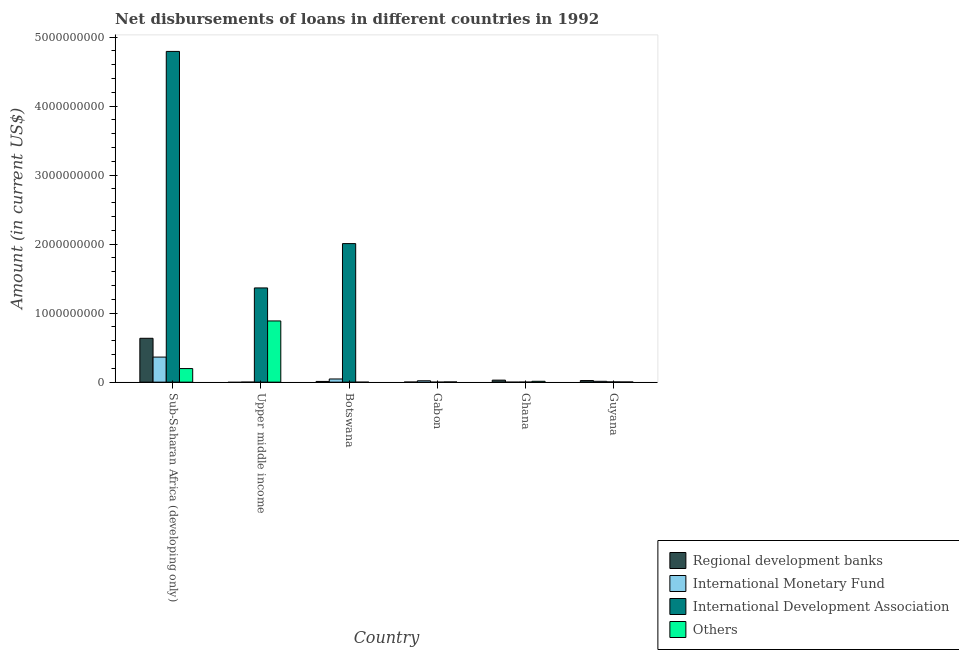How many groups of bars are there?
Provide a succinct answer. 6. Are the number of bars per tick equal to the number of legend labels?
Offer a very short reply. No. Are the number of bars on each tick of the X-axis equal?
Offer a very short reply. No. What is the label of the 5th group of bars from the left?
Provide a short and direct response. Ghana. What is the amount of loan disimbursed by regional development banks in Sub-Saharan Africa (developing only)?
Your answer should be very brief. 6.36e+08. Across all countries, what is the maximum amount of loan disimbursed by other organisations?
Ensure brevity in your answer.  8.87e+08. In which country was the amount of loan disimbursed by international monetary fund maximum?
Keep it short and to the point. Sub-Saharan Africa (developing only). What is the total amount of loan disimbursed by other organisations in the graph?
Make the answer very short. 1.10e+09. What is the difference between the amount of loan disimbursed by international monetary fund in Guyana and that in Sub-Saharan Africa (developing only)?
Provide a short and direct response. -3.51e+08. What is the difference between the amount of loan disimbursed by other organisations in Guyana and the amount of loan disimbursed by regional development banks in Botswana?
Provide a short and direct response. -8.21e+06. What is the average amount of loan disimbursed by other organisations per country?
Offer a very short reply. 1.84e+08. What is the difference between the amount of loan disimbursed by international development association and amount of loan disimbursed by other organisations in Guyana?
Ensure brevity in your answer.  1.00e+06. In how many countries, is the amount of loan disimbursed by international monetary fund greater than 4400000000 US$?
Your answer should be compact. 0. What is the ratio of the amount of loan disimbursed by other organisations in Gabon to that in Guyana?
Your response must be concise. 1.22. What is the difference between the highest and the second highest amount of loan disimbursed by regional development banks?
Your answer should be very brief. 6.07e+08. What is the difference between the highest and the lowest amount of loan disimbursed by international development association?
Give a very brief answer. 4.79e+09. In how many countries, is the amount of loan disimbursed by regional development banks greater than the average amount of loan disimbursed by regional development banks taken over all countries?
Make the answer very short. 1. Is the sum of the amount of loan disimbursed by regional development banks in Guyana and Sub-Saharan Africa (developing only) greater than the maximum amount of loan disimbursed by international development association across all countries?
Offer a terse response. No. Is it the case that in every country, the sum of the amount of loan disimbursed by international monetary fund and amount of loan disimbursed by international development association is greater than the sum of amount of loan disimbursed by regional development banks and amount of loan disimbursed by other organisations?
Ensure brevity in your answer.  No. Is it the case that in every country, the sum of the amount of loan disimbursed by regional development banks and amount of loan disimbursed by international monetary fund is greater than the amount of loan disimbursed by international development association?
Give a very brief answer. No. How many bars are there?
Provide a succinct answer. 18. What is the difference between two consecutive major ticks on the Y-axis?
Provide a succinct answer. 1.00e+09. Are the values on the major ticks of Y-axis written in scientific E-notation?
Provide a short and direct response. No. What is the title of the graph?
Make the answer very short. Net disbursements of loans in different countries in 1992. What is the label or title of the Y-axis?
Your answer should be very brief. Amount (in current US$). What is the Amount (in current US$) in Regional development banks in Sub-Saharan Africa (developing only)?
Your answer should be compact. 6.36e+08. What is the Amount (in current US$) in International Monetary Fund in Sub-Saharan Africa (developing only)?
Keep it short and to the point. 3.63e+08. What is the Amount (in current US$) in International Development Association in Sub-Saharan Africa (developing only)?
Offer a terse response. 4.79e+09. What is the Amount (in current US$) of Others in Sub-Saharan Africa (developing only)?
Your answer should be very brief. 1.97e+08. What is the Amount (in current US$) in International Monetary Fund in Upper middle income?
Your answer should be compact. 0. What is the Amount (in current US$) of International Development Association in Upper middle income?
Ensure brevity in your answer.  1.37e+09. What is the Amount (in current US$) of Others in Upper middle income?
Provide a succinct answer. 8.87e+08. What is the Amount (in current US$) of Regional development banks in Botswana?
Offer a terse response. 1.04e+07. What is the Amount (in current US$) in International Monetary Fund in Botswana?
Ensure brevity in your answer.  4.60e+07. What is the Amount (in current US$) of International Development Association in Botswana?
Your answer should be very brief. 2.01e+09. What is the Amount (in current US$) in Regional development banks in Gabon?
Provide a short and direct response. 9.91e+05. What is the Amount (in current US$) in International Monetary Fund in Gabon?
Your response must be concise. 1.99e+07. What is the Amount (in current US$) in International Development Association in Gabon?
Give a very brief answer. 0. What is the Amount (in current US$) in Others in Gabon?
Offer a very short reply. 2.66e+06. What is the Amount (in current US$) of Regional development banks in Ghana?
Keep it short and to the point. 2.91e+07. What is the Amount (in current US$) in International Monetary Fund in Ghana?
Your answer should be very brief. 0. What is the Amount (in current US$) in International Development Association in Ghana?
Make the answer very short. 0. What is the Amount (in current US$) in Others in Ghana?
Your answer should be compact. 1.25e+07. What is the Amount (in current US$) of Regional development banks in Guyana?
Make the answer very short. 2.32e+07. What is the Amount (in current US$) of International Monetary Fund in Guyana?
Provide a succinct answer. 1.22e+07. What is the Amount (in current US$) of International Development Association in Guyana?
Your answer should be compact. 3.19e+06. What is the Amount (in current US$) of Others in Guyana?
Ensure brevity in your answer.  2.18e+06. Across all countries, what is the maximum Amount (in current US$) in Regional development banks?
Your response must be concise. 6.36e+08. Across all countries, what is the maximum Amount (in current US$) of International Monetary Fund?
Make the answer very short. 3.63e+08. Across all countries, what is the maximum Amount (in current US$) of International Development Association?
Offer a terse response. 4.79e+09. Across all countries, what is the maximum Amount (in current US$) of Others?
Your answer should be compact. 8.87e+08. Across all countries, what is the minimum Amount (in current US$) in Regional development banks?
Keep it short and to the point. 0. Across all countries, what is the minimum Amount (in current US$) in International Monetary Fund?
Your response must be concise. 0. What is the total Amount (in current US$) of Regional development banks in the graph?
Give a very brief answer. 6.99e+08. What is the total Amount (in current US$) in International Monetary Fund in the graph?
Give a very brief answer. 4.41e+08. What is the total Amount (in current US$) of International Development Association in the graph?
Provide a succinct answer. 8.17e+09. What is the total Amount (in current US$) of Others in the graph?
Your answer should be compact. 1.10e+09. What is the difference between the Amount (in current US$) in International Development Association in Sub-Saharan Africa (developing only) and that in Upper middle income?
Offer a very short reply. 3.43e+09. What is the difference between the Amount (in current US$) of Others in Sub-Saharan Africa (developing only) and that in Upper middle income?
Ensure brevity in your answer.  -6.90e+08. What is the difference between the Amount (in current US$) in Regional development banks in Sub-Saharan Africa (developing only) and that in Botswana?
Offer a very short reply. 6.25e+08. What is the difference between the Amount (in current US$) of International Monetary Fund in Sub-Saharan Africa (developing only) and that in Botswana?
Provide a succinct answer. 3.17e+08. What is the difference between the Amount (in current US$) in International Development Association in Sub-Saharan Africa (developing only) and that in Botswana?
Provide a short and direct response. 2.79e+09. What is the difference between the Amount (in current US$) in Regional development banks in Sub-Saharan Africa (developing only) and that in Gabon?
Offer a very short reply. 6.35e+08. What is the difference between the Amount (in current US$) of International Monetary Fund in Sub-Saharan Africa (developing only) and that in Gabon?
Give a very brief answer. 3.43e+08. What is the difference between the Amount (in current US$) of Others in Sub-Saharan Africa (developing only) and that in Gabon?
Make the answer very short. 1.94e+08. What is the difference between the Amount (in current US$) in Regional development banks in Sub-Saharan Africa (developing only) and that in Ghana?
Your response must be concise. 6.07e+08. What is the difference between the Amount (in current US$) of Others in Sub-Saharan Africa (developing only) and that in Ghana?
Your response must be concise. 1.84e+08. What is the difference between the Amount (in current US$) in Regional development banks in Sub-Saharan Africa (developing only) and that in Guyana?
Offer a very short reply. 6.13e+08. What is the difference between the Amount (in current US$) in International Monetary Fund in Sub-Saharan Africa (developing only) and that in Guyana?
Your answer should be very brief. 3.51e+08. What is the difference between the Amount (in current US$) in International Development Association in Sub-Saharan Africa (developing only) and that in Guyana?
Your answer should be compact. 4.79e+09. What is the difference between the Amount (in current US$) in Others in Sub-Saharan Africa (developing only) and that in Guyana?
Your answer should be compact. 1.95e+08. What is the difference between the Amount (in current US$) in International Development Association in Upper middle income and that in Botswana?
Give a very brief answer. -6.43e+08. What is the difference between the Amount (in current US$) in Others in Upper middle income and that in Gabon?
Give a very brief answer. 8.84e+08. What is the difference between the Amount (in current US$) of Others in Upper middle income and that in Ghana?
Your response must be concise. 8.75e+08. What is the difference between the Amount (in current US$) in International Development Association in Upper middle income and that in Guyana?
Keep it short and to the point. 1.36e+09. What is the difference between the Amount (in current US$) in Others in Upper middle income and that in Guyana?
Ensure brevity in your answer.  8.85e+08. What is the difference between the Amount (in current US$) in Regional development banks in Botswana and that in Gabon?
Provide a short and direct response. 9.40e+06. What is the difference between the Amount (in current US$) in International Monetary Fund in Botswana and that in Gabon?
Offer a very short reply. 2.61e+07. What is the difference between the Amount (in current US$) of Regional development banks in Botswana and that in Ghana?
Your answer should be very brief. -1.88e+07. What is the difference between the Amount (in current US$) of Regional development banks in Botswana and that in Guyana?
Keep it short and to the point. -1.28e+07. What is the difference between the Amount (in current US$) in International Monetary Fund in Botswana and that in Guyana?
Provide a short and direct response. 3.38e+07. What is the difference between the Amount (in current US$) of International Development Association in Botswana and that in Guyana?
Give a very brief answer. 2.00e+09. What is the difference between the Amount (in current US$) of Regional development banks in Gabon and that in Ghana?
Provide a short and direct response. -2.82e+07. What is the difference between the Amount (in current US$) of Others in Gabon and that in Ghana?
Make the answer very short. -9.86e+06. What is the difference between the Amount (in current US$) in Regional development banks in Gabon and that in Guyana?
Provide a short and direct response. -2.22e+07. What is the difference between the Amount (in current US$) in International Monetary Fund in Gabon and that in Guyana?
Ensure brevity in your answer.  7.66e+06. What is the difference between the Amount (in current US$) in Others in Gabon and that in Guyana?
Keep it short and to the point. 4.79e+05. What is the difference between the Amount (in current US$) of Regional development banks in Ghana and that in Guyana?
Offer a terse response. 5.97e+06. What is the difference between the Amount (in current US$) of Others in Ghana and that in Guyana?
Offer a very short reply. 1.03e+07. What is the difference between the Amount (in current US$) in Regional development banks in Sub-Saharan Africa (developing only) and the Amount (in current US$) in International Development Association in Upper middle income?
Keep it short and to the point. -7.30e+08. What is the difference between the Amount (in current US$) of Regional development banks in Sub-Saharan Africa (developing only) and the Amount (in current US$) of Others in Upper middle income?
Your response must be concise. -2.51e+08. What is the difference between the Amount (in current US$) in International Monetary Fund in Sub-Saharan Africa (developing only) and the Amount (in current US$) in International Development Association in Upper middle income?
Provide a short and direct response. -1.00e+09. What is the difference between the Amount (in current US$) in International Monetary Fund in Sub-Saharan Africa (developing only) and the Amount (in current US$) in Others in Upper middle income?
Keep it short and to the point. -5.24e+08. What is the difference between the Amount (in current US$) of International Development Association in Sub-Saharan Africa (developing only) and the Amount (in current US$) of Others in Upper middle income?
Keep it short and to the point. 3.91e+09. What is the difference between the Amount (in current US$) of Regional development banks in Sub-Saharan Africa (developing only) and the Amount (in current US$) of International Monetary Fund in Botswana?
Your answer should be compact. 5.90e+08. What is the difference between the Amount (in current US$) in Regional development banks in Sub-Saharan Africa (developing only) and the Amount (in current US$) in International Development Association in Botswana?
Offer a terse response. -1.37e+09. What is the difference between the Amount (in current US$) in International Monetary Fund in Sub-Saharan Africa (developing only) and the Amount (in current US$) in International Development Association in Botswana?
Provide a short and direct response. -1.64e+09. What is the difference between the Amount (in current US$) in Regional development banks in Sub-Saharan Africa (developing only) and the Amount (in current US$) in International Monetary Fund in Gabon?
Your answer should be compact. 6.16e+08. What is the difference between the Amount (in current US$) of Regional development banks in Sub-Saharan Africa (developing only) and the Amount (in current US$) of Others in Gabon?
Your response must be concise. 6.33e+08. What is the difference between the Amount (in current US$) in International Monetary Fund in Sub-Saharan Africa (developing only) and the Amount (in current US$) in Others in Gabon?
Offer a very short reply. 3.60e+08. What is the difference between the Amount (in current US$) of International Development Association in Sub-Saharan Africa (developing only) and the Amount (in current US$) of Others in Gabon?
Your answer should be compact. 4.79e+09. What is the difference between the Amount (in current US$) of Regional development banks in Sub-Saharan Africa (developing only) and the Amount (in current US$) of Others in Ghana?
Your answer should be very brief. 6.23e+08. What is the difference between the Amount (in current US$) in International Monetary Fund in Sub-Saharan Africa (developing only) and the Amount (in current US$) in Others in Ghana?
Your response must be concise. 3.51e+08. What is the difference between the Amount (in current US$) of International Development Association in Sub-Saharan Africa (developing only) and the Amount (in current US$) of Others in Ghana?
Give a very brief answer. 4.78e+09. What is the difference between the Amount (in current US$) in Regional development banks in Sub-Saharan Africa (developing only) and the Amount (in current US$) in International Monetary Fund in Guyana?
Offer a very short reply. 6.23e+08. What is the difference between the Amount (in current US$) in Regional development banks in Sub-Saharan Africa (developing only) and the Amount (in current US$) in International Development Association in Guyana?
Your response must be concise. 6.33e+08. What is the difference between the Amount (in current US$) of Regional development banks in Sub-Saharan Africa (developing only) and the Amount (in current US$) of Others in Guyana?
Provide a succinct answer. 6.34e+08. What is the difference between the Amount (in current US$) of International Monetary Fund in Sub-Saharan Africa (developing only) and the Amount (in current US$) of International Development Association in Guyana?
Provide a short and direct response. 3.60e+08. What is the difference between the Amount (in current US$) of International Monetary Fund in Sub-Saharan Africa (developing only) and the Amount (in current US$) of Others in Guyana?
Your response must be concise. 3.61e+08. What is the difference between the Amount (in current US$) in International Development Association in Sub-Saharan Africa (developing only) and the Amount (in current US$) in Others in Guyana?
Keep it short and to the point. 4.79e+09. What is the difference between the Amount (in current US$) in International Development Association in Upper middle income and the Amount (in current US$) in Others in Gabon?
Your answer should be compact. 1.36e+09. What is the difference between the Amount (in current US$) of International Development Association in Upper middle income and the Amount (in current US$) of Others in Ghana?
Offer a terse response. 1.35e+09. What is the difference between the Amount (in current US$) of International Development Association in Upper middle income and the Amount (in current US$) of Others in Guyana?
Keep it short and to the point. 1.36e+09. What is the difference between the Amount (in current US$) of Regional development banks in Botswana and the Amount (in current US$) of International Monetary Fund in Gabon?
Make the answer very short. -9.50e+06. What is the difference between the Amount (in current US$) in Regional development banks in Botswana and the Amount (in current US$) in Others in Gabon?
Give a very brief answer. 7.73e+06. What is the difference between the Amount (in current US$) of International Monetary Fund in Botswana and the Amount (in current US$) of Others in Gabon?
Your answer should be very brief. 4.33e+07. What is the difference between the Amount (in current US$) of International Development Association in Botswana and the Amount (in current US$) of Others in Gabon?
Your response must be concise. 2.01e+09. What is the difference between the Amount (in current US$) of Regional development banks in Botswana and the Amount (in current US$) of Others in Ghana?
Make the answer very short. -2.13e+06. What is the difference between the Amount (in current US$) in International Monetary Fund in Botswana and the Amount (in current US$) in Others in Ghana?
Provide a succinct answer. 3.35e+07. What is the difference between the Amount (in current US$) in International Development Association in Botswana and the Amount (in current US$) in Others in Ghana?
Provide a short and direct response. 2.00e+09. What is the difference between the Amount (in current US$) in Regional development banks in Botswana and the Amount (in current US$) in International Monetary Fund in Guyana?
Provide a short and direct response. -1.84e+06. What is the difference between the Amount (in current US$) in Regional development banks in Botswana and the Amount (in current US$) in International Development Association in Guyana?
Your response must be concise. 7.20e+06. What is the difference between the Amount (in current US$) in Regional development banks in Botswana and the Amount (in current US$) in Others in Guyana?
Provide a succinct answer. 8.21e+06. What is the difference between the Amount (in current US$) in International Monetary Fund in Botswana and the Amount (in current US$) in International Development Association in Guyana?
Your response must be concise. 4.28e+07. What is the difference between the Amount (in current US$) in International Monetary Fund in Botswana and the Amount (in current US$) in Others in Guyana?
Your answer should be very brief. 4.38e+07. What is the difference between the Amount (in current US$) of International Development Association in Botswana and the Amount (in current US$) of Others in Guyana?
Your response must be concise. 2.01e+09. What is the difference between the Amount (in current US$) of Regional development banks in Gabon and the Amount (in current US$) of Others in Ghana?
Your response must be concise. -1.15e+07. What is the difference between the Amount (in current US$) of International Monetary Fund in Gabon and the Amount (in current US$) of Others in Ghana?
Ensure brevity in your answer.  7.36e+06. What is the difference between the Amount (in current US$) in Regional development banks in Gabon and the Amount (in current US$) in International Monetary Fund in Guyana?
Your answer should be compact. -1.12e+07. What is the difference between the Amount (in current US$) of Regional development banks in Gabon and the Amount (in current US$) of International Development Association in Guyana?
Offer a terse response. -2.20e+06. What is the difference between the Amount (in current US$) in Regional development banks in Gabon and the Amount (in current US$) in Others in Guyana?
Your response must be concise. -1.19e+06. What is the difference between the Amount (in current US$) in International Monetary Fund in Gabon and the Amount (in current US$) in International Development Association in Guyana?
Provide a short and direct response. 1.67e+07. What is the difference between the Amount (in current US$) in International Monetary Fund in Gabon and the Amount (in current US$) in Others in Guyana?
Provide a succinct answer. 1.77e+07. What is the difference between the Amount (in current US$) in Regional development banks in Ghana and the Amount (in current US$) in International Monetary Fund in Guyana?
Your response must be concise. 1.69e+07. What is the difference between the Amount (in current US$) in Regional development banks in Ghana and the Amount (in current US$) in International Development Association in Guyana?
Make the answer very short. 2.60e+07. What is the difference between the Amount (in current US$) in Regional development banks in Ghana and the Amount (in current US$) in Others in Guyana?
Provide a succinct answer. 2.70e+07. What is the average Amount (in current US$) of Regional development banks per country?
Give a very brief answer. 1.17e+08. What is the average Amount (in current US$) in International Monetary Fund per country?
Give a very brief answer. 7.35e+07. What is the average Amount (in current US$) in International Development Association per country?
Ensure brevity in your answer.  1.36e+09. What is the average Amount (in current US$) in Others per country?
Offer a very short reply. 1.84e+08. What is the difference between the Amount (in current US$) of Regional development banks and Amount (in current US$) of International Monetary Fund in Sub-Saharan Africa (developing only)?
Offer a terse response. 2.73e+08. What is the difference between the Amount (in current US$) in Regional development banks and Amount (in current US$) in International Development Association in Sub-Saharan Africa (developing only)?
Your answer should be very brief. -4.16e+09. What is the difference between the Amount (in current US$) in Regional development banks and Amount (in current US$) in Others in Sub-Saharan Africa (developing only)?
Your answer should be very brief. 4.39e+08. What is the difference between the Amount (in current US$) of International Monetary Fund and Amount (in current US$) of International Development Association in Sub-Saharan Africa (developing only)?
Give a very brief answer. -4.43e+09. What is the difference between the Amount (in current US$) of International Monetary Fund and Amount (in current US$) of Others in Sub-Saharan Africa (developing only)?
Offer a very short reply. 1.66e+08. What is the difference between the Amount (in current US$) of International Development Association and Amount (in current US$) of Others in Sub-Saharan Africa (developing only)?
Offer a terse response. 4.60e+09. What is the difference between the Amount (in current US$) in International Development Association and Amount (in current US$) in Others in Upper middle income?
Offer a terse response. 4.78e+08. What is the difference between the Amount (in current US$) of Regional development banks and Amount (in current US$) of International Monetary Fund in Botswana?
Make the answer very short. -3.56e+07. What is the difference between the Amount (in current US$) of Regional development banks and Amount (in current US$) of International Development Association in Botswana?
Offer a very short reply. -2.00e+09. What is the difference between the Amount (in current US$) in International Monetary Fund and Amount (in current US$) in International Development Association in Botswana?
Provide a short and direct response. -1.96e+09. What is the difference between the Amount (in current US$) in Regional development banks and Amount (in current US$) in International Monetary Fund in Gabon?
Keep it short and to the point. -1.89e+07. What is the difference between the Amount (in current US$) in Regional development banks and Amount (in current US$) in Others in Gabon?
Your answer should be compact. -1.67e+06. What is the difference between the Amount (in current US$) in International Monetary Fund and Amount (in current US$) in Others in Gabon?
Offer a terse response. 1.72e+07. What is the difference between the Amount (in current US$) of Regional development banks and Amount (in current US$) of Others in Ghana?
Provide a short and direct response. 1.66e+07. What is the difference between the Amount (in current US$) in Regional development banks and Amount (in current US$) in International Monetary Fund in Guyana?
Keep it short and to the point. 1.09e+07. What is the difference between the Amount (in current US$) of Regional development banks and Amount (in current US$) of International Development Association in Guyana?
Provide a short and direct response. 2.00e+07. What is the difference between the Amount (in current US$) in Regional development banks and Amount (in current US$) in Others in Guyana?
Make the answer very short. 2.10e+07. What is the difference between the Amount (in current US$) of International Monetary Fund and Amount (in current US$) of International Development Association in Guyana?
Provide a short and direct response. 9.05e+06. What is the difference between the Amount (in current US$) of International Monetary Fund and Amount (in current US$) of Others in Guyana?
Offer a very short reply. 1.00e+07. What is the difference between the Amount (in current US$) of International Development Association and Amount (in current US$) of Others in Guyana?
Provide a short and direct response. 1.00e+06. What is the ratio of the Amount (in current US$) in International Development Association in Sub-Saharan Africa (developing only) to that in Upper middle income?
Keep it short and to the point. 3.51. What is the ratio of the Amount (in current US$) in Others in Sub-Saharan Africa (developing only) to that in Upper middle income?
Your response must be concise. 0.22. What is the ratio of the Amount (in current US$) of Regional development banks in Sub-Saharan Africa (developing only) to that in Botswana?
Make the answer very short. 61.17. What is the ratio of the Amount (in current US$) of International Monetary Fund in Sub-Saharan Africa (developing only) to that in Botswana?
Provide a succinct answer. 7.9. What is the ratio of the Amount (in current US$) of International Development Association in Sub-Saharan Africa (developing only) to that in Botswana?
Provide a short and direct response. 2.39. What is the ratio of the Amount (in current US$) of Regional development banks in Sub-Saharan Africa (developing only) to that in Gabon?
Provide a short and direct response. 641.46. What is the ratio of the Amount (in current US$) in International Monetary Fund in Sub-Saharan Africa (developing only) to that in Gabon?
Your answer should be very brief. 18.26. What is the ratio of the Amount (in current US$) of Others in Sub-Saharan Africa (developing only) to that in Gabon?
Keep it short and to the point. 73.91. What is the ratio of the Amount (in current US$) in Regional development banks in Sub-Saharan Africa (developing only) to that in Ghana?
Make the answer very short. 21.81. What is the ratio of the Amount (in current US$) in Others in Sub-Saharan Africa (developing only) to that in Ghana?
Keep it short and to the point. 15.71. What is the ratio of the Amount (in current US$) in Regional development banks in Sub-Saharan Africa (developing only) to that in Guyana?
Provide a succinct answer. 27.43. What is the ratio of the Amount (in current US$) of International Monetary Fund in Sub-Saharan Africa (developing only) to that in Guyana?
Offer a terse response. 29.68. What is the ratio of the Amount (in current US$) of International Development Association in Sub-Saharan Africa (developing only) to that in Guyana?
Give a very brief answer. 1503.64. What is the ratio of the Amount (in current US$) in Others in Sub-Saharan Africa (developing only) to that in Guyana?
Keep it short and to the point. 90.12. What is the ratio of the Amount (in current US$) of International Development Association in Upper middle income to that in Botswana?
Make the answer very short. 0.68. What is the ratio of the Amount (in current US$) in Others in Upper middle income to that in Gabon?
Ensure brevity in your answer.  333.12. What is the ratio of the Amount (in current US$) in Others in Upper middle income to that in Ghana?
Keep it short and to the point. 70.81. What is the ratio of the Amount (in current US$) of International Development Association in Upper middle income to that in Guyana?
Keep it short and to the point. 428.33. What is the ratio of the Amount (in current US$) in Others in Upper middle income to that in Guyana?
Ensure brevity in your answer.  406.18. What is the ratio of the Amount (in current US$) of Regional development banks in Botswana to that in Gabon?
Make the answer very short. 10.49. What is the ratio of the Amount (in current US$) in International Monetary Fund in Botswana to that in Gabon?
Keep it short and to the point. 2.31. What is the ratio of the Amount (in current US$) in Regional development banks in Botswana to that in Ghana?
Provide a succinct answer. 0.36. What is the ratio of the Amount (in current US$) in Regional development banks in Botswana to that in Guyana?
Keep it short and to the point. 0.45. What is the ratio of the Amount (in current US$) of International Monetary Fund in Botswana to that in Guyana?
Your answer should be compact. 3.76. What is the ratio of the Amount (in current US$) of International Development Association in Botswana to that in Guyana?
Offer a very short reply. 629.88. What is the ratio of the Amount (in current US$) of Regional development banks in Gabon to that in Ghana?
Your response must be concise. 0.03. What is the ratio of the Amount (in current US$) in Others in Gabon to that in Ghana?
Your answer should be very brief. 0.21. What is the ratio of the Amount (in current US$) of Regional development banks in Gabon to that in Guyana?
Your response must be concise. 0.04. What is the ratio of the Amount (in current US$) in International Monetary Fund in Gabon to that in Guyana?
Keep it short and to the point. 1.63. What is the ratio of the Amount (in current US$) of Others in Gabon to that in Guyana?
Your response must be concise. 1.22. What is the ratio of the Amount (in current US$) in Regional development banks in Ghana to that in Guyana?
Give a very brief answer. 1.26. What is the ratio of the Amount (in current US$) in Others in Ghana to that in Guyana?
Offer a terse response. 5.74. What is the difference between the highest and the second highest Amount (in current US$) in Regional development banks?
Offer a very short reply. 6.07e+08. What is the difference between the highest and the second highest Amount (in current US$) of International Monetary Fund?
Your answer should be very brief. 3.17e+08. What is the difference between the highest and the second highest Amount (in current US$) of International Development Association?
Provide a short and direct response. 2.79e+09. What is the difference between the highest and the second highest Amount (in current US$) in Others?
Offer a very short reply. 6.90e+08. What is the difference between the highest and the lowest Amount (in current US$) of Regional development banks?
Keep it short and to the point. 6.36e+08. What is the difference between the highest and the lowest Amount (in current US$) of International Monetary Fund?
Provide a short and direct response. 3.63e+08. What is the difference between the highest and the lowest Amount (in current US$) of International Development Association?
Offer a terse response. 4.79e+09. What is the difference between the highest and the lowest Amount (in current US$) in Others?
Ensure brevity in your answer.  8.87e+08. 